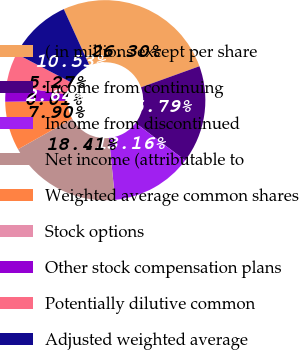Convert chart. <chart><loc_0><loc_0><loc_500><loc_500><pie_chart><fcel>( in millions except per share<fcel>Income from continuing<fcel>Income from discontinued<fcel>Net income (attributable to<fcel>Weighted average common shares<fcel>Stock options<fcel>Other stock compensation plans<fcel>Potentially dilutive common<fcel>Adjusted weighted average<nl><fcel>26.3%<fcel>15.79%<fcel>13.16%<fcel>18.41%<fcel>7.9%<fcel>0.01%<fcel>2.64%<fcel>5.27%<fcel>10.53%<nl></chart> 